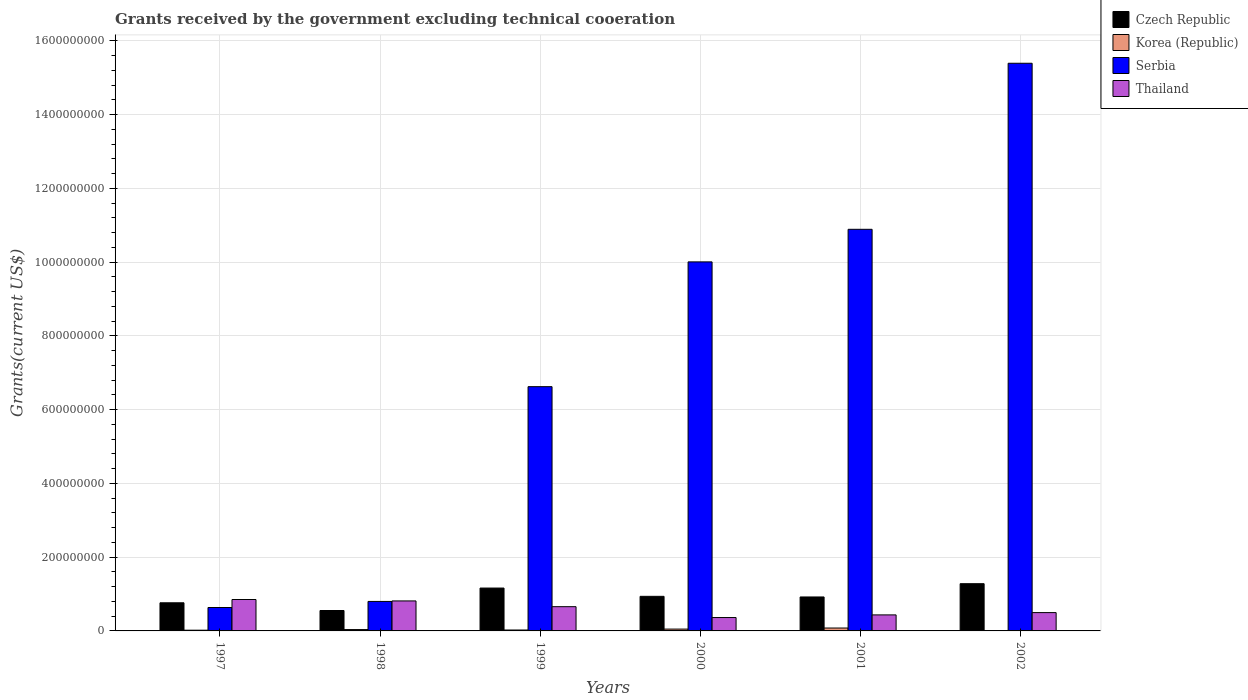What is the label of the 5th group of bars from the left?
Keep it short and to the point. 2001. In how many cases, is the number of bars for a given year not equal to the number of legend labels?
Your response must be concise. 0. What is the total grants received by the government in Thailand in 2000?
Provide a short and direct response. 3.63e+07. Across all years, what is the maximum total grants received by the government in Thailand?
Ensure brevity in your answer.  8.52e+07. Across all years, what is the minimum total grants received by the government in Serbia?
Offer a terse response. 6.35e+07. In which year was the total grants received by the government in Thailand maximum?
Give a very brief answer. 1997. What is the total total grants received by the government in Thailand in the graph?
Offer a terse response. 3.62e+08. What is the difference between the total grants received by the government in Serbia in 1998 and that in 2000?
Give a very brief answer. -9.21e+08. What is the difference between the total grants received by the government in Korea (Republic) in 1997 and the total grants received by the government in Thailand in 2001?
Ensure brevity in your answer.  -4.15e+07. What is the average total grants received by the government in Serbia per year?
Your response must be concise. 7.39e+08. In the year 1997, what is the difference between the total grants received by the government in Serbia and total grants received by the government in Korea (Republic)?
Your answer should be compact. 6.16e+07. What is the ratio of the total grants received by the government in Thailand in 1999 to that in 2002?
Offer a very short reply. 1.32. Is the difference between the total grants received by the government in Serbia in 1999 and 2001 greater than the difference between the total grants received by the government in Korea (Republic) in 1999 and 2001?
Offer a very short reply. No. What is the difference between the highest and the second highest total grants received by the government in Korea (Republic)?
Ensure brevity in your answer.  2.88e+06. What is the difference between the highest and the lowest total grants received by the government in Korea (Republic)?
Make the answer very short. 7.22e+06. In how many years, is the total grants received by the government in Thailand greater than the average total grants received by the government in Thailand taken over all years?
Ensure brevity in your answer.  3. What does the 4th bar from the left in 1999 represents?
Keep it short and to the point. Thailand. Is it the case that in every year, the sum of the total grants received by the government in Thailand and total grants received by the government in Czech Republic is greater than the total grants received by the government in Serbia?
Ensure brevity in your answer.  No. How many bars are there?
Give a very brief answer. 24. Are all the bars in the graph horizontal?
Offer a very short reply. No. How many years are there in the graph?
Your answer should be compact. 6. What is the difference between two consecutive major ticks on the Y-axis?
Offer a terse response. 2.00e+08. Does the graph contain any zero values?
Your answer should be very brief. No. Where does the legend appear in the graph?
Offer a terse response. Top right. How many legend labels are there?
Provide a short and direct response. 4. How are the legend labels stacked?
Give a very brief answer. Vertical. What is the title of the graph?
Provide a succinct answer. Grants received by the government excluding technical cooeration. What is the label or title of the X-axis?
Your answer should be very brief. Years. What is the label or title of the Y-axis?
Make the answer very short. Grants(current US$). What is the Grants(current US$) of Czech Republic in 1997?
Give a very brief answer. 7.63e+07. What is the Grants(current US$) in Korea (Republic) in 1997?
Ensure brevity in your answer.  1.95e+06. What is the Grants(current US$) of Serbia in 1997?
Your answer should be compact. 6.35e+07. What is the Grants(current US$) of Thailand in 1997?
Make the answer very short. 8.52e+07. What is the Grants(current US$) in Czech Republic in 1998?
Offer a terse response. 5.54e+07. What is the Grants(current US$) of Korea (Republic) in 1998?
Ensure brevity in your answer.  3.65e+06. What is the Grants(current US$) in Serbia in 1998?
Offer a very short reply. 8.00e+07. What is the Grants(current US$) in Thailand in 1998?
Offer a very short reply. 8.13e+07. What is the Grants(current US$) of Czech Republic in 1999?
Offer a very short reply. 1.16e+08. What is the Grants(current US$) of Korea (Republic) in 1999?
Make the answer very short. 2.48e+06. What is the Grants(current US$) in Serbia in 1999?
Give a very brief answer. 6.62e+08. What is the Grants(current US$) of Thailand in 1999?
Ensure brevity in your answer.  6.57e+07. What is the Grants(current US$) of Czech Republic in 2000?
Your answer should be very brief. 9.38e+07. What is the Grants(current US$) in Korea (Republic) in 2000?
Give a very brief answer. 4.97e+06. What is the Grants(current US$) of Serbia in 2000?
Your answer should be compact. 1.00e+09. What is the Grants(current US$) of Thailand in 2000?
Keep it short and to the point. 3.63e+07. What is the Grants(current US$) of Czech Republic in 2001?
Provide a succinct answer. 9.21e+07. What is the Grants(current US$) of Korea (Republic) in 2001?
Provide a short and direct response. 7.85e+06. What is the Grants(current US$) in Serbia in 2001?
Your answer should be compact. 1.09e+09. What is the Grants(current US$) in Thailand in 2001?
Offer a terse response. 4.34e+07. What is the Grants(current US$) of Czech Republic in 2002?
Give a very brief answer. 1.28e+08. What is the Grants(current US$) of Korea (Republic) in 2002?
Provide a short and direct response. 6.30e+05. What is the Grants(current US$) of Serbia in 2002?
Provide a short and direct response. 1.54e+09. What is the Grants(current US$) in Thailand in 2002?
Provide a short and direct response. 4.97e+07. Across all years, what is the maximum Grants(current US$) of Czech Republic?
Give a very brief answer. 1.28e+08. Across all years, what is the maximum Grants(current US$) of Korea (Republic)?
Your response must be concise. 7.85e+06. Across all years, what is the maximum Grants(current US$) of Serbia?
Offer a very short reply. 1.54e+09. Across all years, what is the maximum Grants(current US$) of Thailand?
Keep it short and to the point. 8.52e+07. Across all years, what is the minimum Grants(current US$) in Czech Republic?
Provide a succinct answer. 5.54e+07. Across all years, what is the minimum Grants(current US$) in Korea (Republic)?
Give a very brief answer. 6.30e+05. Across all years, what is the minimum Grants(current US$) in Serbia?
Your response must be concise. 6.35e+07. Across all years, what is the minimum Grants(current US$) of Thailand?
Ensure brevity in your answer.  3.63e+07. What is the total Grants(current US$) in Czech Republic in the graph?
Provide a short and direct response. 5.62e+08. What is the total Grants(current US$) of Korea (Republic) in the graph?
Your answer should be compact. 2.15e+07. What is the total Grants(current US$) of Serbia in the graph?
Provide a short and direct response. 4.43e+09. What is the total Grants(current US$) of Thailand in the graph?
Ensure brevity in your answer.  3.62e+08. What is the difference between the Grants(current US$) of Czech Republic in 1997 and that in 1998?
Your answer should be compact. 2.09e+07. What is the difference between the Grants(current US$) of Korea (Republic) in 1997 and that in 1998?
Give a very brief answer. -1.70e+06. What is the difference between the Grants(current US$) of Serbia in 1997 and that in 1998?
Your answer should be compact. -1.65e+07. What is the difference between the Grants(current US$) of Thailand in 1997 and that in 1998?
Give a very brief answer. 3.85e+06. What is the difference between the Grants(current US$) of Czech Republic in 1997 and that in 1999?
Your response must be concise. -3.99e+07. What is the difference between the Grants(current US$) of Korea (Republic) in 1997 and that in 1999?
Your answer should be very brief. -5.30e+05. What is the difference between the Grants(current US$) of Serbia in 1997 and that in 1999?
Provide a succinct answer. -5.99e+08. What is the difference between the Grants(current US$) in Thailand in 1997 and that in 1999?
Your answer should be very brief. 1.94e+07. What is the difference between the Grants(current US$) in Czech Republic in 1997 and that in 2000?
Keep it short and to the point. -1.75e+07. What is the difference between the Grants(current US$) of Korea (Republic) in 1997 and that in 2000?
Provide a succinct answer. -3.02e+06. What is the difference between the Grants(current US$) of Serbia in 1997 and that in 2000?
Your answer should be very brief. -9.37e+08. What is the difference between the Grants(current US$) in Thailand in 1997 and that in 2000?
Ensure brevity in your answer.  4.89e+07. What is the difference between the Grants(current US$) in Czech Republic in 1997 and that in 2001?
Make the answer very short. -1.58e+07. What is the difference between the Grants(current US$) in Korea (Republic) in 1997 and that in 2001?
Offer a terse response. -5.90e+06. What is the difference between the Grants(current US$) of Serbia in 1997 and that in 2001?
Ensure brevity in your answer.  -1.03e+09. What is the difference between the Grants(current US$) in Thailand in 1997 and that in 2001?
Make the answer very short. 4.17e+07. What is the difference between the Grants(current US$) of Czech Republic in 1997 and that in 2002?
Your response must be concise. -5.18e+07. What is the difference between the Grants(current US$) of Korea (Republic) in 1997 and that in 2002?
Ensure brevity in your answer.  1.32e+06. What is the difference between the Grants(current US$) in Serbia in 1997 and that in 2002?
Give a very brief answer. -1.48e+09. What is the difference between the Grants(current US$) of Thailand in 1997 and that in 2002?
Give a very brief answer. 3.55e+07. What is the difference between the Grants(current US$) of Czech Republic in 1998 and that in 1999?
Ensure brevity in your answer.  -6.09e+07. What is the difference between the Grants(current US$) in Korea (Republic) in 1998 and that in 1999?
Your answer should be very brief. 1.17e+06. What is the difference between the Grants(current US$) in Serbia in 1998 and that in 1999?
Provide a succinct answer. -5.82e+08. What is the difference between the Grants(current US$) of Thailand in 1998 and that in 1999?
Provide a succinct answer. 1.56e+07. What is the difference between the Grants(current US$) in Czech Republic in 1998 and that in 2000?
Offer a terse response. -3.84e+07. What is the difference between the Grants(current US$) in Korea (Republic) in 1998 and that in 2000?
Offer a terse response. -1.32e+06. What is the difference between the Grants(current US$) of Serbia in 1998 and that in 2000?
Your response must be concise. -9.21e+08. What is the difference between the Grants(current US$) of Thailand in 1998 and that in 2000?
Make the answer very short. 4.50e+07. What is the difference between the Grants(current US$) in Czech Republic in 1998 and that in 2001?
Provide a succinct answer. -3.67e+07. What is the difference between the Grants(current US$) of Korea (Republic) in 1998 and that in 2001?
Give a very brief answer. -4.20e+06. What is the difference between the Grants(current US$) in Serbia in 1998 and that in 2001?
Provide a succinct answer. -1.01e+09. What is the difference between the Grants(current US$) in Thailand in 1998 and that in 2001?
Ensure brevity in your answer.  3.79e+07. What is the difference between the Grants(current US$) of Czech Republic in 1998 and that in 2002?
Your answer should be compact. -7.27e+07. What is the difference between the Grants(current US$) of Korea (Republic) in 1998 and that in 2002?
Offer a terse response. 3.02e+06. What is the difference between the Grants(current US$) in Serbia in 1998 and that in 2002?
Your response must be concise. -1.46e+09. What is the difference between the Grants(current US$) in Thailand in 1998 and that in 2002?
Your answer should be compact. 3.17e+07. What is the difference between the Grants(current US$) in Czech Republic in 1999 and that in 2000?
Your answer should be compact. 2.24e+07. What is the difference between the Grants(current US$) in Korea (Republic) in 1999 and that in 2000?
Keep it short and to the point. -2.49e+06. What is the difference between the Grants(current US$) of Serbia in 1999 and that in 2000?
Offer a very short reply. -3.38e+08. What is the difference between the Grants(current US$) in Thailand in 1999 and that in 2000?
Provide a short and direct response. 2.94e+07. What is the difference between the Grants(current US$) of Czech Republic in 1999 and that in 2001?
Keep it short and to the point. 2.42e+07. What is the difference between the Grants(current US$) of Korea (Republic) in 1999 and that in 2001?
Keep it short and to the point. -5.37e+06. What is the difference between the Grants(current US$) in Serbia in 1999 and that in 2001?
Your answer should be compact. -4.27e+08. What is the difference between the Grants(current US$) in Thailand in 1999 and that in 2001?
Keep it short and to the point. 2.23e+07. What is the difference between the Grants(current US$) of Czech Republic in 1999 and that in 2002?
Ensure brevity in your answer.  -1.19e+07. What is the difference between the Grants(current US$) of Korea (Republic) in 1999 and that in 2002?
Make the answer very short. 1.85e+06. What is the difference between the Grants(current US$) of Serbia in 1999 and that in 2002?
Give a very brief answer. -8.77e+08. What is the difference between the Grants(current US$) of Thailand in 1999 and that in 2002?
Keep it short and to the point. 1.61e+07. What is the difference between the Grants(current US$) in Czech Republic in 2000 and that in 2001?
Give a very brief answer. 1.70e+06. What is the difference between the Grants(current US$) of Korea (Republic) in 2000 and that in 2001?
Offer a terse response. -2.88e+06. What is the difference between the Grants(current US$) in Serbia in 2000 and that in 2001?
Ensure brevity in your answer.  -8.84e+07. What is the difference between the Grants(current US$) in Thailand in 2000 and that in 2001?
Ensure brevity in your answer.  -7.15e+06. What is the difference between the Grants(current US$) in Czech Republic in 2000 and that in 2002?
Your answer should be compact. -3.43e+07. What is the difference between the Grants(current US$) in Korea (Republic) in 2000 and that in 2002?
Your answer should be very brief. 4.34e+06. What is the difference between the Grants(current US$) of Serbia in 2000 and that in 2002?
Your response must be concise. -5.39e+08. What is the difference between the Grants(current US$) of Thailand in 2000 and that in 2002?
Your response must be concise. -1.34e+07. What is the difference between the Grants(current US$) in Czech Republic in 2001 and that in 2002?
Ensure brevity in your answer.  -3.60e+07. What is the difference between the Grants(current US$) in Korea (Republic) in 2001 and that in 2002?
Provide a short and direct response. 7.22e+06. What is the difference between the Grants(current US$) of Serbia in 2001 and that in 2002?
Your response must be concise. -4.50e+08. What is the difference between the Grants(current US$) in Thailand in 2001 and that in 2002?
Provide a succinct answer. -6.21e+06. What is the difference between the Grants(current US$) in Czech Republic in 1997 and the Grants(current US$) in Korea (Republic) in 1998?
Ensure brevity in your answer.  7.26e+07. What is the difference between the Grants(current US$) of Czech Republic in 1997 and the Grants(current US$) of Serbia in 1998?
Your answer should be very brief. -3.71e+06. What is the difference between the Grants(current US$) in Czech Republic in 1997 and the Grants(current US$) in Thailand in 1998?
Keep it short and to the point. -5.04e+06. What is the difference between the Grants(current US$) in Korea (Republic) in 1997 and the Grants(current US$) in Serbia in 1998?
Your response must be concise. -7.80e+07. What is the difference between the Grants(current US$) of Korea (Republic) in 1997 and the Grants(current US$) of Thailand in 1998?
Provide a succinct answer. -7.94e+07. What is the difference between the Grants(current US$) in Serbia in 1997 and the Grants(current US$) in Thailand in 1998?
Ensure brevity in your answer.  -1.78e+07. What is the difference between the Grants(current US$) in Czech Republic in 1997 and the Grants(current US$) in Korea (Republic) in 1999?
Your response must be concise. 7.38e+07. What is the difference between the Grants(current US$) of Czech Republic in 1997 and the Grants(current US$) of Serbia in 1999?
Your response must be concise. -5.86e+08. What is the difference between the Grants(current US$) in Czech Republic in 1997 and the Grants(current US$) in Thailand in 1999?
Give a very brief answer. 1.06e+07. What is the difference between the Grants(current US$) of Korea (Republic) in 1997 and the Grants(current US$) of Serbia in 1999?
Your response must be concise. -6.60e+08. What is the difference between the Grants(current US$) of Korea (Republic) in 1997 and the Grants(current US$) of Thailand in 1999?
Ensure brevity in your answer.  -6.38e+07. What is the difference between the Grants(current US$) of Serbia in 1997 and the Grants(current US$) of Thailand in 1999?
Ensure brevity in your answer.  -2.23e+06. What is the difference between the Grants(current US$) of Czech Republic in 1997 and the Grants(current US$) of Korea (Republic) in 2000?
Offer a very short reply. 7.13e+07. What is the difference between the Grants(current US$) in Czech Republic in 1997 and the Grants(current US$) in Serbia in 2000?
Provide a short and direct response. -9.24e+08. What is the difference between the Grants(current US$) of Czech Republic in 1997 and the Grants(current US$) of Thailand in 2000?
Ensure brevity in your answer.  4.00e+07. What is the difference between the Grants(current US$) in Korea (Republic) in 1997 and the Grants(current US$) in Serbia in 2000?
Provide a succinct answer. -9.99e+08. What is the difference between the Grants(current US$) of Korea (Republic) in 1997 and the Grants(current US$) of Thailand in 2000?
Make the answer very short. -3.44e+07. What is the difference between the Grants(current US$) in Serbia in 1997 and the Grants(current US$) in Thailand in 2000?
Provide a short and direct response. 2.72e+07. What is the difference between the Grants(current US$) of Czech Republic in 1997 and the Grants(current US$) of Korea (Republic) in 2001?
Your answer should be compact. 6.84e+07. What is the difference between the Grants(current US$) of Czech Republic in 1997 and the Grants(current US$) of Serbia in 2001?
Give a very brief answer. -1.01e+09. What is the difference between the Grants(current US$) of Czech Republic in 1997 and the Grants(current US$) of Thailand in 2001?
Provide a short and direct response. 3.28e+07. What is the difference between the Grants(current US$) in Korea (Republic) in 1997 and the Grants(current US$) in Serbia in 2001?
Offer a very short reply. -1.09e+09. What is the difference between the Grants(current US$) in Korea (Republic) in 1997 and the Grants(current US$) in Thailand in 2001?
Make the answer very short. -4.15e+07. What is the difference between the Grants(current US$) in Serbia in 1997 and the Grants(current US$) in Thailand in 2001?
Keep it short and to the point. 2.00e+07. What is the difference between the Grants(current US$) in Czech Republic in 1997 and the Grants(current US$) in Korea (Republic) in 2002?
Give a very brief answer. 7.56e+07. What is the difference between the Grants(current US$) of Czech Republic in 1997 and the Grants(current US$) of Serbia in 2002?
Ensure brevity in your answer.  -1.46e+09. What is the difference between the Grants(current US$) of Czech Republic in 1997 and the Grants(current US$) of Thailand in 2002?
Provide a succinct answer. 2.66e+07. What is the difference between the Grants(current US$) in Korea (Republic) in 1997 and the Grants(current US$) in Serbia in 2002?
Offer a very short reply. -1.54e+09. What is the difference between the Grants(current US$) of Korea (Republic) in 1997 and the Grants(current US$) of Thailand in 2002?
Offer a terse response. -4.77e+07. What is the difference between the Grants(current US$) of Serbia in 1997 and the Grants(current US$) of Thailand in 2002?
Keep it short and to the point. 1.38e+07. What is the difference between the Grants(current US$) of Czech Republic in 1998 and the Grants(current US$) of Korea (Republic) in 1999?
Offer a terse response. 5.29e+07. What is the difference between the Grants(current US$) in Czech Republic in 1998 and the Grants(current US$) in Serbia in 1999?
Provide a succinct answer. -6.07e+08. What is the difference between the Grants(current US$) of Czech Republic in 1998 and the Grants(current US$) of Thailand in 1999?
Your answer should be very brief. -1.04e+07. What is the difference between the Grants(current US$) in Korea (Republic) in 1998 and the Grants(current US$) in Serbia in 1999?
Offer a terse response. -6.59e+08. What is the difference between the Grants(current US$) in Korea (Republic) in 1998 and the Grants(current US$) in Thailand in 1999?
Your answer should be compact. -6.21e+07. What is the difference between the Grants(current US$) in Serbia in 1998 and the Grants(current US$) in Thailand in 1999?
Keep it short and to the point. 1.43e+07. What is the difference between the Grants(current US$) of Czech Republic in 1998 and the Grants(current US$) of Korea (Republic) in 2000?
Ensure brevity in your answer.  5.04e+07. What is the difference between the Grants(current US$) in Czech Republic in 1998 and the Grants(current US$) in Serbia in 2000?
Offer a terse response. -9.45e+08. What is the difference between the Grants(current US$) in Czech Republic in 1998 and the Grants(current US$) in Thailand in 2000?
Your answer should be compact. 1.91e+07. What is the difference between the Grants(current US$) of Korea (Republic) in 1998 and the Grants(current US$) of Serbia in 2000?
Your answer should be compact. -9.97e+08. What is the difference between the Grants(current US$) in Korea (Republic) in 1998 and the Grants(current US$) in Thailand in 2000?
Your answer should be compact. -3.26e+07. What is the difference between the Grants(current US$) in Serbia in 1998 and the Grants(current US$) in Thailand in 2000?
Your response must be concise. 4.37e+07. What is the difference between the Grants(current US$) in Czech Republic in 1998 and the Grants(current US$) in Korea (Republic) in 2001?
Your answer should be compact. 4.75e+07. What is the difference between the Grants(current US$) in Czech Republic in 1998 and the Grants(current US$) in Serbia in 2001?
Provide a succinct answer. -1.03e+09. What is the difference between the Grants(current US$) in Czech Republic in 1998 and the Grants(current US$) in Thailand in 2001?
Make the answer very short. 1.19e+07. What is the difference between the Grants(current US$) in Korea (Republic) in 1998 and the Grants(current US$) in Serbia in 2001?
Offer a very short reply. -1.09e+09. What is the difference between the Grants(current US$) of Korea (Republic) in 1998 and the Grants(current US$) of Thailand in 2001?
Your answer should be compact. -3.98e+07. What is the difference between the Grants(current US$) in Serbia in 1998 and the Grants(current US$) in Thailand in 2001?
Your answer should be very brief. 3.65e+07. What is the difference between the Grants(current US$) of Czech Republic in 1998 and the Grants(current US$) of Korea (Republic) in 2002?
Provide a succinct answer. 5.47e+07. What is the difference between the Grants(current US$) of Czech Republic in 1998 and the Grants(current US$) of Serbia in 2002?
Your answer should be very brief. -1.48e+09. What is the difference between the Grants(current US$) of Czech Republic in 1998 and the Grants(current US$) of Thailand in 2002?
Your answer should be compact. 5.70e+06. What is the difference between the Grants(current US$) in Korea (Republic) in 1998 and the Grants(current US$) in Serbia in 2002?
Offer a terse response. -1.54e+09. What is the difference between the Grants(current US$) of Korea (Republic) in 1998 and the Grants(current US$) of Thailand in 2002?
Offer a very short reply. -4.60e+07. What is the difference between the Grants(current US$) of Serbia in 1998 and the Grants(current US$) of Thailand in 2002?
Give a very brief answer. 3.03e+07. What is the difference between the Grants(current US$) in Czech Republic in 1999 and the Grants(current US$) in Korea (Republic) in 2000?
Offer a terse response. 1.11e+08. What is the difference between the Grants(current US$) of Czech Republic in 1999 and the Grants(current US$) of Serbia in 2000?
Provide a succinct answer. -8.84e+08. What is the difference between the Grants(current US$) in Czech Republic in 1999 and the Grants(current US$) in Thailand in 2000?
Provide a short and direct response. 7.99e+07. What is the difference between the Grants(current US$) in Korea (Republic) in 1999 and the Grants(current US$) in Serbia in 2000?
Keep it short and to the point. -9.98e+08. What is the difference between the Grants(current US$) in Korea (Republic) in 1999 and the Grants(current US$) in Thailand in 2000?
Ensure brevity in your answer.  -3.38e+07. What is the difference between the Grants(current US$) of Serbia in 1999 and the Grants(current US$) of Thailand in 2000?
Provide a short and direct response. 6.26e+08. What is the difference between the Grants(current US$) of Czech Republic in 1999 and the Grants(current US$) of Korea (Republic) in 2001?
Your answer should be compact. 1.08e+08. What is the difference between the Grants(current US$) of Czech Republic in 1999 and the Grants(current US$) of Serbia in 2001?
Provide a succinct answer. -9.73e+08. What is the difference between the Grants(current US$) of Czech Republic in 1999 and the Grants(current US$) of Thailand in 2001?
Your response must be concise. 7.28e+07. What is the difference between the Grants(current US$) in Korea (Republic) in 1999 and the Grants(current US$) in Serbia in 2001?
Provide a short and direct response. -1.09e+09. What is the difference between the Grants(current US$) of Korea (Republic) in 1999 and the Grants(current US$) of Thailand in 2001?
Your answer should be very brief. -4.10e+07. What is the difference between the Grants(current US$) in Serbia in 1999 and the Grants(current US$) in Thailand in 2001?
Your response must be concise. 6.19e+08. What is the difference between the Grants(current US$) in Czech Republic in 1999 and the Grants(current US$) in Korea (Republic) in 2002?
Your answer should be compact. 1.16e+08. What is the difference between the Grants(current US$) in Czech Republic in 1999 and the Grants(current US$) in Serbia in 2002?
Ensure brevity in your answer.  -1.42e+09. What is the difference between the Grants(current US$) in Czech Republic in 1999 and the Grants(current US$) in Thailand in 2002?
Offer a very short reply. 6.66e+07. What is the difference between the Grants(current US$) in Korea (Republic) in 1999 and the Grants(current US$) in Serbia in 2002?
Your response must be concise. -1.54e+09. What is the difference between the Grants(current US$) of Korea (Republic) in 1999 and the Grants(current US$) of Thailand in 2002?
Your answer should be compact. -4.72e+07. What is the difference between the Grants(current US$) in Serbia in 1999 and the Grants(current US$) in Thailand in 2002?
Provide a succinct answer. 6.13e+08. What is the difference between the Grants(current US$) of Czech Republic in 2000 and the Grants(current US$) of Korea (Republic) in 2001?
Offer a very short reply. 8.59e+07. What is the difference between the Grants(current US$) in Czech Republic in 2000 and the Grants(current US$) in Serbia in 2001?
Make the answer very short. -9.95e+08. What is the difference between the Grants(current US$) in Czech Republic in 2000 and the Grants(current US$) in Thailand in 2001?
Your answer should be very brief. 5.03e+07. What is the difference between the Grants(current US$) in Korea (Republic) in 2000 and the Grants(current US$) in Serbia in 2001?
Give a very brief answer. -1.08e+09. What is the difference between the Grants(current US$) in Korea (Republic) in 2000 and the Grants(current US$) in Thailand in 2001?
Your response must be concise. -3.85e+07. What is the difference between the Grants(current US$) in Serbia in 2000 and the Grants(current US$) in Thailand in 2001?
Your response must be concise. 9.57e+08. What is the difference between the Grants(current US$) in Czech Republic in 2000 and the Grants(current US$) in Korea (Republic) in 2002?
Provide a succinct answer. 9.31e+07. What is the difference between the Grants(current US$) of Czech Republic in 2000 and the Grants(current US$) of Serbia in 2002?
Offer a terse response. -1.45e+09. What is the difference between the Grants(current US$) of Czech Republic in 2000 and the Grants(current US$) of Thailand in 2002?
Provide a short and direct response. 4.41e+07. What is the difference between the Grants(current US$) in Korea (Republic) in 2000 and the Grants(current US$) in Serbia in 2002?
Make the answer very short. -1.53e+09. What is the difference between the Grants(current US$) of Korea (Republic) in 2000 and the Grants(current US$) of Thailand in 2002?
Your answer should be compact. -4.47e+07. What is the difference between the Grants(current US$) of Serbia in 2000 and the Grants(current US$) of Thailand in 2002?
Give a very brief answer. 9.51e+08. What is the difference between the Grants(current US$) in Czech Republic in 2001 and the Grants(current US$) in Korea (Republic) in 2002?
Ensure brevity in your answer.  9.14e+07. What is the difference between the Grants(current US$) of Czech Republic in 2001 and the Grants(current US$) of Serbia in 2002?
Your answer should be compact. -1.45e+09. What is the difference between the Grants(current US$) in Czech Republic in 2001 and the Grants(current US$) in Thailand in 2002?
Your response must be concise. 4.24e+07. What is the difference between the Grants(current US$) of Korea (Republic) in 2001 and the Grants(current US$) of Serbia in 2002?
Ensure brevity in your answer.  -1.53e+09. What is the difference between the Grants(current US$) of Korea (Republic) in 2001 and the Grants(current US$) of Thailand in 2002?
Make the answer very short. -4.18e+07. What is the difference between the Grants(current US$) of Serbia in 2001 and the Grants(current US$) of Thailand in 2002?
Your answer should be very brief. 1.04e+09. What is the average Grants(current US$) of Czech Republic per year?
Provide a short and direct response. 9.36e+07. What is the average Grants(current US$) of Korea (Republic) per year?
Make the answer very short. 3.59e+06. What is the average Grants(current US$) of Serbia per year?
Offer a terse response. 7.39e+08. What is the average Grants(current US$) of Thailand per year?
Your response must be concise. 6.03e+07. In the year 1997, what is the difference between the Grants(current US$) in Czech Republic and Grants(current US$) in Korea (Republic)?
Your answer should be compact. 7.43e+07. In the year 1997, what is the difference between the Grants(current US$) of Czech Republic and Grants(current US$) of Serbia?
Your answer should be compact. 1.28e+07. In the year 1997, what is the difference between the Grants(current US$) of Czech Republic and Grants(current US$) of Thailand?
Give a very brief answer. -8.89e+06. In the year 1997, what is the difference between the Grants(current US$) of Korea (Republic) and Grants(current US$) of Serbia?
Offer a very short reply. -6.16e+07. In the year 1997, what is the difference between the Grants(current US$) in Korea (Republic) and Grants(current US$) in Thailand?
Your answer should be compact. -8.32e+07. In the year 1997, what is the difference between the Grants(current US$) of Serbia and Grants(current US$) of Thailand?
Make the answer very short. -2.17e+07. In the year 1998, what is the difference between the Grants(current US$) of Czech Republic and Grants(current US$) of Korea (Republic)?
Keep it short and to the point. 5.17e+07. In the year 1998, what is the difference between the Grants(current US$) of Czech Republic and Grants(current US$) of Serbia?
Ensure brevity in your answer.  -2.46e+07. In the year 1998, what is the difference between the Grants(current US$) of Czech Republic and Grants(current US$) of Thailand?
Your answer should be very brief. -2.60e+07. In the year 1998, what is the difference between the Grants(current US$) of Korea (Republic) and Grants(current US$) of Serbia?
Provide a succinct answer. -7.63e+07. In the year 1998, what is the difference between the Grants(current US$) of Korea (Republic) and Grants(current US$) of Thailand?
Provide a short and direct response. -7.77e+07. In the year 1998, what is the difference between the Grants(current US$) in Serbia and Grants(current US$) in Thailand?
Ensure brevity in your answer.  -1.33e+06. In the year 1999, what is the difference between the Grants(current US$) in Czech Republic and Grants(current US$) in Korea (Republic)?
Your response must be concise. 1.14e+08. In the year 1999, what is the difference between the Grants(current US$) of Czech Republic and Grants(current US$) of Serbia?
Make the answer very short. -5.46e+08. In the year 1999, what is the difference between the Grants(current US$) in Czech Republic and Grants(current US$) in Thailand?
Ensure brevity in your answer.  5.05e+07. In the year 1999, what is the difference between the Grants(current US$) in Korea (Republic) and Grants(current US$) in Serbia?
Your answer should be compact. -6.60e+08. In the year 1999, what is the difference between the Grants(current US$) in Korea (Republic) and Grants(current US$) in Thailand?
Ensure brevity in your answer.  -6.32e+07. In the year 1999, what is the difference between the Grants(current US$) in Serbia and Grants(current US$) in Thailand?
Provide a short and direct response. 5.97e+08. In the year 2000, what is the difference between the Grants(current US$) in Czech Republic and Grants(current US$) in Korea (Republic)?
Give a very brief answer. 8.88e+07. In the year 2000, what is the difference between the Grants(current US$) in Czech Republic and Grants(current US$) in Serbia?
Give a very brief answer. -9.07e+08. In the year 2000, what is the difference between the Grants(current US$) in Czech Republic and Grants(current US$) in Thailand?
Your response must be concise. 5.75e+07. In the year 2000, what is the difference between the Grants(current US$) in Korea (Republic) and Grants(current US$) in Serbia?
Give a very brief answer. -9.96e+08. In the year 2000, what is the difference between the Grants(current US$) in Korea (Republic) and Grants(current US$) in Thailand?
Give a very brief answer. -3.13e+07. In the year 2000, what is the difference between the Grants(current US$) of Serbia and Grants(current US$) of Thailand?
Provide a short and direct response. 9.64e+08. In the year 2001, what is the difference between the Grants(current US$) of Czech Republic and Grants(current US$) of Korea (Republic)?
Your answer should be very brief. 8.42e+07. In the year 2001, what is the difference between the Grants(current US$) in Czech Republic and Grants(current US$) in Serbia?
Offer a very short reply. -9.97e+08. In the year 2001, what is the difference between the Grants(current US$) of Czech Republic and Grants(current US$) of Thailand?
Offer a terse response. 4.86e+07. In the year 2001, what is the difference between the Grants(current US$) of Korea (Republic) and Grants(current US$) of Serbia?
Offer a very short reply. -1.08e+09. In the year 2001, what is the difference between the Grants(current US$) of Korea (Republic) and Grants(current US$) of Thailand?
Your response must be concise. -3.56e+07. In the year 2001, what is the difference between the Grants(current US$) in Serbia and Grants(current US$) in Thailand?
Your response must be concise. 1.05e+09. In the year 2002, what is the difference between the Grants(current US$) in Czech Republic and Grants(current US$) in Korea (Republic)?
Provide a succinct answer. 1.27e+08. In the year 2002, what is the difference between the Grants(current US$) of Czech Republic and Grants(current US$) of Serbia?
Make the answer very short. -1.41e+09. In the year 2002, what is the difference between the Grants(current US$) in Czech Republic and Grants(current US$) in Thailand?
Your response must be concise. 7.84e+07. In the year 2002, what is the difference between the Grants(current US$) of Korea (Republic) and Grants(current US$) of Serbia?
Keep it short and to the point. -1.54e+09. In the year 2002, what is the difference between the Grants(current US$) of Korea (Republic) and Grants(current US$) of Thailand?
Your answer should be compact. -4.90e+07. In the year 2002, what is the difference between the Grants(current US$) of Serbia and Grants(current US$) of Thailand?
Make the answer very short. 1.49e+09. What is the ratio of the Grants(current US$) of Czech Republic in 1997 to that in 1998?
Keep it short and to the point. 1.38. What is the ratio of the Grants(current US$) of Korea (Republic) in 1997 to that in 1998?
Offer a terse response. 0.53. What is the ratio of the Grants(current US$) in Serbia in 1997 to that in 1998?
Offer a terse response. 0.79. What is the ratio of the Grants(current US$) of Thailand in 1997 to that in 1998?
Offer a terse response. 1.05. What is the ratio of the Grants(current US$) in Czech Republic in 1997 to that in 1999?
Provide a succinct answer. 0.66. What is the ratio of the Grants(current US$) of Korea (Republic) in 1997 to that in 1999?
Your answer should be compact. 0.79. What is the ratio of the Grants(current US$) of Serbia in 1997 to that in 1999?
Provide a succinct answer. 0.1. What is the ratio of the Grants(current US$) in Thailand in 1997 to that in 1999?
Your answer should be compact. 1.3. What is the ratio of the Grants(current US$) in Czech Republic in 1997 to that in 2000?
Your answer should be compact. 0.81. What is the ratio of the Grants(current US$) of Korea (Republic) in 1997 to that in 2000?
Keep it short and to the point. 0.39. What is the ratio of the Grants(current US$) in Serbia in 1997 to that in 2000?
Provide a succinct answer. 0.06. What is the ratio of the Grants(current US$) of Thailand in 1997 to that in 2000?
Ensure brevity in your answer.  2.35. What is the ratio of the Grants(current US$) in Czech Republic in 1997 to that in 2001?
Offer a terse response. 0.83. What is the ratio of the Grants(current US$) of Korea (Republic) in 1997 to that in 2001?
Provide a succinct answer. 0.25. What is the ratio of the Grants(current US$) in Serbia in 1997 to that in 2001?
Make the answer very short. 0.06. What is the ratio of the Grants(current US$) in Thailand in 1997 to that in 2001?
Offer a terse response. 1.96. What is the ratio of the Grants(current US$) of Czech Republic in 1997 to that in 2002?
Your answer should be very brief. 0.6. What is the ratio of the Grants(current US$) in Korea (Republic) in 1997 to that in 2002?
Give a very brief answer. 3.1. What is the ratio of the Grants(current US$) in Serbia in 1997 to that in 2002?
Offer a very short reply. 0.04. What is the ratio of the Grants(current US$) in Thailand in 1997 to that in 2002?
Provide a succinct answer. 1.72. What is the ratio of the Grants(current US$) of Czech Republic in 1998 to that in 1999?
Your answer should be compact. 0.48. What is the ratio of the Grants(current US$) of Korea (Republic) in 1998 to that in 1999?
Your answer should be very brief. 1.47. What is the ratio of the Grants(current US$) of Serbia in 1998 to that in 1999?
Keep it short and to the point. 0.12. What is the ratio of the Grants(current US$) of Thailand in 1998 to that in 1999?
Give a very brief answer. 1.24. What is the ratio of the Grants(current US$) in Czech Republic in 1998 to that in 2000?
Give a very brief answer. 0.59. What is the ratio of the Grants(current US$) of Korea (Republic) in 1998 to that in 2000?
Your answer should be very brief. 0.73. What is the ratio of the Grants(current US$) of Serbia in 1998 to that in 2000?
Offer a terse response. 0.08. What is the ratio of the Grants(current US$) of Thailand in 1998 to that in 2000?
Your answer should be compact. 2.24. What is the ratio of the Grants(current US$) in Czech Republic in 1998 to that in 2001?
Keep it short and to the point. 0.6. What is the ratio of the Grants(current US$) in Korea (Republic) in 1998 to that in 2001?
Your answer should be very brief. 0.47. What is the ratio of the Grants(current US$) of Serbia in 1998 to that in 2001?
Provide a short and direct response. 0.07. What is the ratio of the Grants(current US$) of Thailand in 1998 to that in 2001?
Offer a very short reply. 1.87. What is the ratio of the Grants(current US$) in Czech Republic in 1998 to that in 2002?
Your response must be concise. 0.43. What is the ratio of the Grants(current US$) in Korea (Republic) in 1998 to that in 2002?
Your answer should be very brief. 5.79. What is the ratio of the Grants(current US$) of Serbia in 1998 to that in 2002?
Provide a short and direct response. 0.05. What is the ratio of the Grants(current US$) of Thailand in 1998 to that in 2002?
Offer a very short reply. 1.64. What is the ratio of the Grants(current US$) in Czech Republic in 1999 to that in 2000?
Make the answer very short. 1.24. What is the ratio of the Grants(current US$) in Korea (Republic) in 1999 to that in 2000?
Your answer should be very brief. 0.5. What is the ratio of the Grants(current US$) in Serbia in 1999 to that in 2000?
Offer a very short reply. 0.66. What is the ratio of the Grants(current US$) of Thailand in 1999 to that in 2000?
Provide a succinct answer. 1.81. What is the ratio of the Grants(current US$) of Czech Republic in 1999 to that in 2001?
Offer a very short reply. 1.26. What is the ratio of the Grants(current US$) in Korea (Republic) in 1999 to that in 2001?
Give a very brief answer. 0.32. What is the ratio of the Grants(current US$) of Serbia in 1999 to that in 2001?
Your answer should be compact. 0.61. What is the ratio of the Grants(current US$) of Thailand in 1999 to that in 2001?
Ensure brevity in your answer.  1.51. What is the ratio of the Grants(current US$) of Czech Republic in 1999 to that in 2002?
Provide a short and direct response. 0.91. What is the ratio of the Grants(current US$) of Korea (Republic) in 1999 to that in 2002?
Offer a terse response. 3.94. What is the ratio of the Grants(current US$) in Serbia in 1999 to that in 2002?
Give a very brief answer. 0.43. What is the ratio of the Grants(current US$) in Thailand in 1999 to that in 2002?
Provide a succinct answer. 1.32. What is the ratio of the Grants(current US$) in Czech Republic in 2000 to that in 2001?
Offer a terse response. 1.02. What is the ratio of the Grants(current US$) in Korea (Republic) in 2000 to that in 2001?
Your response must be concise. 0.63. What is the ratio of the Grants(current US$) of Serbia in 2000 to that in 2001?
Make the answer very short. 0.92. What is the ratio of the Grants(current US$) of Thailand in 2000 to that in 2001?
Your answer should be very brief. 0.84. What is the ratio of the Grants(current US$) of Czech Republic in 2000 to that in 2002?
Keep it short and to the point. 0.73. What is the ratio of the Grants(current US$) in Korea (Republic) in 2000 to that in 2002?
Your answer should be very brief. 7.89. What is the ratio of the Grants(current US$) in Serbia in 2000 to that in 2002?
Provide a succinct answer. 0.65. What is the ratio of the Grants(current US$) of Thailand in 2000 to that in 2002?
Make the answer very short. 0.73. What is the ratio of the Grants(current US$) of Czech Republic in 2001 to that in 2002?
Keep it short and to the point. 0.72. What is the ratio of the Grants(current US$) in Korea (Republic) in 2001 to that in 2002?
Give a very brief answer. 12.46. What is the ratio of the Grants(current US$) in Serbia in 2001 to that in 2002?
Provide a short and direct response. 0.71. What is the ratio of the Grants(current US$) of Thailand in 2001 to that in 2002?
Make the answer very short. 0.87. What is the difference between the highest and the second highest Grants(current US$) of Czech Republic?
Offer a terse response. 1.19e+07. What is the difference between the highest and the second highest Grants(current US$) of Korea (Republic)?
Your answer should be very brief. 2.88e+06. What is the difference between the highest and the second highest Grants(current US$) of Serbia?
Your answer should be compact. 4.50e+08. What is the difference between the highest and the second highest Grants(current US$) of Thailand?
Make the answer very short. 3.85e+06. What is the difference between the highest and the lowest Grants(current US$) of Czech Republic?
Your response must be concise. 7.27e+07. What is the difference between the highest and the lowest Grants(current US$) of Korea (Republic)?
Make the answer very short. 7.22e+06. What is the difference between the highest and the lowest Grants(current US$) in Serbia?
Offer a terse response. 1.48e+09. What is the difference between the highest and the lowest Grants(current US$) in Thailand?
Your answer should be very brief. 4.89e+07. 